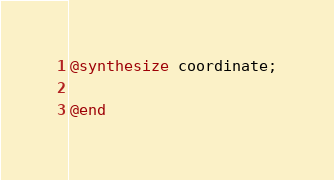<code> <loc_0><loc_0><loc_500><loc_500><_ObjectiveC_>
@synthesize coordinate;

@end
</code> 